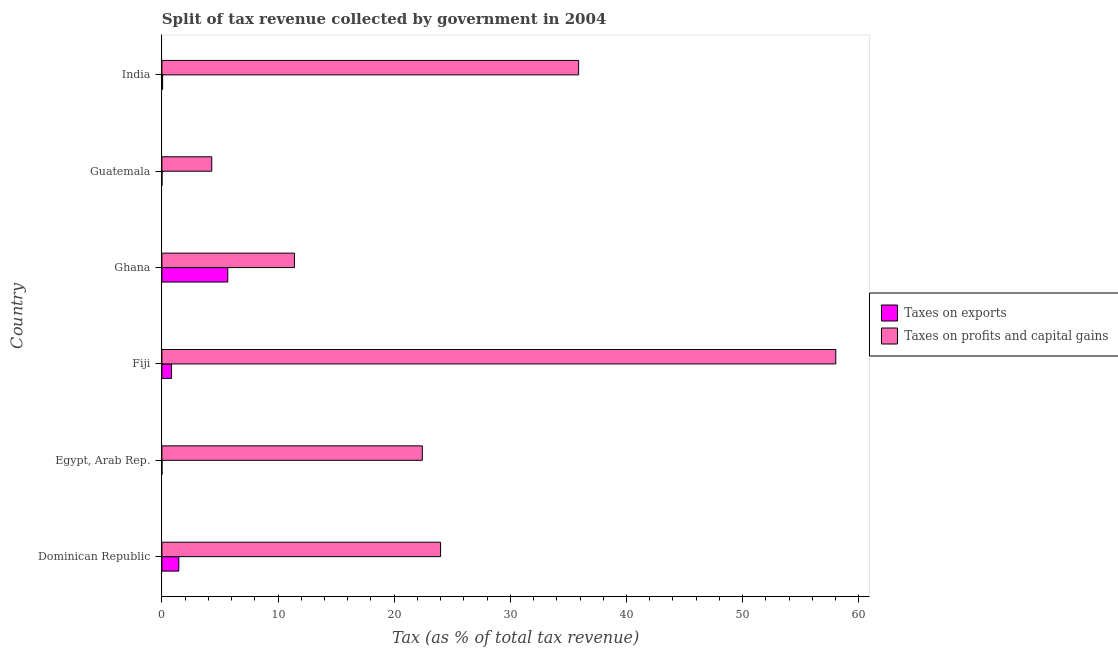How many groups of bars are there?
Your answer should be very brief. 6. Are the number of bars per tick equal to the number of legend labels?
Offer a very short reply. Yes. Are the number of bars on each tick of the Y-axis equal?
Ensure brevity in your answer.  Yes. How many bars are there on the 3rd tick from the top?
Your answer should be very brief. 2. What is the label of the 6th group of bars from the top?
Your response must be concise. Dominican Republic. In how many cases, is the number of bars for a given country not equal to the number of legend labels?
Ensure brevity in your answer.  0. What is the percentage of revenue obtained from taxes on exports in Egypt, Arab Rep.?
Provide a succinct answer. 0. Across all countries, what is the maximum percentage of revenue obtained from taxes on profits and capital gains?
Ensure brevity in your answer.  58.02. Across all countries, what is the minimum percentage of revenue obtained from taxes on exports?
Keep it short and to the point. 0. In which country was the percentage of revenue obtained from taxes on profits and capital gains maximum?
Your answer should be very brief. Fiji. In which country was the percentage of revenue obtained from taxes on exports minimum?
Your answer should be compact. Egypt, Arab Rep. What is the total percentage of revenue obtained from taxes on exports in the graph?
Make the answer very short. 8.03. What is the difference between the percentage of revenue obtained from taxes on exports in Dominican Republic and that in Guatemala?
Give a very brief answer. 1.45. What is the difference between the percentage of revenue obtained from taxes on exports in Dominican Republic and the percentage of revenue obtained from taxes on profits and capital gains in Egypt, Arab Rep.?
Ensure brevity in your answer.  -20.96. What is the average percentage of revenue obtained from taxes on exports per country?
Offer a terse response. 1.34. What is the difference between the percentage of revenue obtained from taxes on profits and capital gains and percentage of revenue obtained from taxes on exports in Fiji?
Provide a short and direct response. 57.19. What is the ratio of the percentage of revenue obtained from taxes on exports in Egypt, Arab Rep. to that in India?
Your response must be concise. 0.05. Is the difference between the percentage of revenue obtained from taxes on profits and capital gains in Dominican Republic and India greater than the difference between the percentage of revenue obtained from taxes on exports in Dominican Republic and India?
Ensure brevity in your answer.  No. What is the difference between the highest and the second highest percentage of revenue obtained from taxes on profits and capital gains?
Make the answer very short. 22.14. What is the difference between the highest and the lowest percentage of revenue obtained from taxes on profits and capital gains?
Ensure brevity in your answer.  53.72. What does the 1st bar from the top in Ghana represents?
Ensure brevity in your answer.  Taxes on profits and capital gains. What does the 2nd bar from the bottom in Guatemala represents?
Provide a short and direct response. Taxes on profits and capital gains. Are all the bars in the graph horizontal?
Offer a very short reply. Yes. Are the values on the major ticks of X-axis written in scientific E-notation?
Your answer should be very brief. No. How are the legend labels stacked?
Your answer should be very brief. Vertical. What is the title of the graph?
Ensure brevity in your answer.  Split of tax revenue collected by government in 2004. What is the label or title of the X-axis?
Provide a short and direct response. Tax (as % of total tax revenue). What is the label or title of the Y-axis?
Keep it short and to the point. Country. What is the Tax (as % of total tax revenue) in Taxes on exports in Dominican Republic?
Make the answer very short. 1.46. What is the Tax (as % of total tax revenue) in Taxes on profits and capital gains in Dominican Republic?
Your answer should be compact. 23.99. What is the Tax (as % of total tax revenue) of Taxes on exports in Egypt, Arab Rep.?
Provide a succinct answer. 0. What is the Tax (as % of total tax revenue) of Taxes on profits and capital gains in Egypt, Arab Rep.?
Provide a succinct answer. 22.42. What is the Tax (as % of total tax revenue) of Taxes on exports in Fiji?
Offer a very short reply. 0.83. What is the Tax (as % of total tax revenue) in Taxes on profits and capital gains in Fiji?
Give a very brief answer. 58.02. What is the Tax (as % of total tax revenue) of Taxes on exports in Ghana?
Provide a short and direct response. 5.67. What is the Tax (as % of total tax revenue) in Taxes on profits and capital gains in Ghana?
Make the answer very short. 11.41. What is the Tax (as % of total tax revenue) in Taxes on exports in Guatemala?
Provide a succinct answer. 0. What is the Tax (as % of total tax revenue) in Taxes on profits and capital gains in Guatemala?
Make the answer very short. 4.29. What is the Tax (as % of total tax revenue) in Taxes on exports in India?
Offer a terse response. 0.06. What is the Tax (as % of total tax revenue) in Taxes on profits and capital gains in India?
Your response must be concise. 35.88. Across all countries, what is the maximum Tax (as % of total tax revenue) in Taxes on exports?
Provide a short and direct response. 5.67. Across all countries, what is the maximum Tax (as % of total tax revenue) in Taxes on profits and capital gains?
Provide a short and direct response. 58.02. Across all countries, what is the minimum Tax (as % of total tax revenue) in Taxes on exports?
Provide a short and direct response. 0. Across all countries, what is the minimum Tax (as % of total tax revenue) in Taxes on profits and capital gains?
Provide a succinct answer. 4.29. What is the total Tax (as % of total tax revenue) in Taxes on exports in the graph?
Offer a very short reply. 8.03. What is the total Tax (as % of total tax revenue) in Taxes on profits and capital gains in the graph?
Keep it short and to the point. 156.01. What is the difference between the Tax (as % of total tax revenue) in Taxes on exports in Dominican Republic and that in Egypt, Arab Rep.?
Your answer should be compact. 1.45. What is the difference between the Tax (as % of total tax revenue) in Taxes on profits and capital gains in Dominican Republic and that in Egypt, Arab Rep.?
Offer a terse response. 1.57. What is the difference between the Tax (as % of total tax revenue) of Taxes on exports in Dominican Republic and that in Fiji?
Your answer should be very brief. 0.63. What is the difference between the Tax (as % of total tax revenue) in Taxes on profits and capital gains in Dominican Republic and that in Fiji?
Provide a short and direct response. -34.02. What is the difference between the Tax (as % of total tax revenue) in Taxes on exports in Dominican Republic and that in Ghana?
Keep it short and to the point. -4.22. What is the difference between the Tax (as % of total tax revenue) in Taxes on profits and capital gains in Dominican Republic and that in Ghana?
Keep it short and to the point. 12.58. What is the difference between the Tax (as % of total tax revenue) of Taxes on exports in Dominican Republic and that in Guatemala?
Offer a terse response. 1.45. What is the difference between the Tax (as % of total tax revenue) of Taxes on profits and capital gains in Dominican Republic and that in Guatemala?
Offer a very short reply. 19.7. What is the difference between the Tax (as % of total tax revenue) in Taxes on exports in Dominican Republic and that in India?
Provide a short and direct response. 1.39. What is the difference between the Tax (as % of total tax revenue) in Taxes on profits and capital gains in Dominican Republic and that in India?
Offer a terse response. -11.89. What is the difference between the Tax (as % of total tax revenue) of Taxes on exports in Egypt, Arab Rep. and that in Fiji?
Keep it short and to the point. -0.83. What is the difference between the Tax (as % of total tax revenue) of Taxes on profits and capital gains in Egypt, Arab Rep. and that in Fiji?
Your response must be concise. -35.6. What is the difference between the Tax (as % of total tax revenue) of Taxes on exports in Egypt, Arab Rep. and that in Ghana?
Give a very brief answer. -5.67. What is the difference between the Tax (as % of total tax revenue) of Taxes on profits and capital gains in Egypt, Arab Rep. and that in Ghana?
Ensure brevity in your answer.  11.01. What is the difference between the Tax (as % of total tax revenue) of Taxes on exports in Egypt, Arab Rep. and that in Guatemala?
Ensure brevity in your answer.  -0. What is the difference between the Tax (as % of total tax revenue) in Taxes on profits and capital gains in Egypt, Arab Rep. and that in Guatemala?
Make the answer very short. 18.13. What is the difference between the Tax (as % of total tax revenue) of Taxes on exports in Egypt, Arab Rep. and that in India?
Offer a very short reply. -0.06. What is the difference between the Tax (as % of total tax revenue) of Taxes on profits and capital gains in Egypt, Arab Rep. and that in India?
Offer a terse response. -13.46. What is the difference between the Tax (as % of total tax revenue) in Taxes on exports in Fiji and that in Ghana?
Give a very brief answer. -4.84. What is the difference between the Tax (as % of total tax revenue) of Taxes on profits and capital gains in Fiji and that in Ghana?
Your response must be concise. 46.61. What is the difference between the Tax (as % of total tax revenue) of Taxes on exports in Fiji and that in Guatemala?
Provide a short and direct response. 0.83. What is the difference between the Tax (as % of total tax revenue) of Taxes on profits and capital gains in Fiji and that in Guatemala?
Make the answer very short. 53.72. What is the difference between the Tax (as % of total tax revenue) of Taxes on exports in Fiji and that in India?
Offer a terse response. 0.77. What is the difference between the Tax (as % of total tax revenue) of Taxes on profits and capital gains in Fiji and that in India?
Offer a very short reply. 22.14. What is the difference between the Tax (as % of total tax revenue) of Taxes on exports in Ghana and that in Guatemala?
Your answer should be very brief. 5.67. What is the difference between the Tax (as % of total tax revenue) in Taxes on profits and capital gains in Ghana and that in Guatemala?
Make the answer very short. 7.12. What is the difference between the Tax (as % of total tax revenue) of Taxes on exports in Ghana and that in India?
Offer a terse response. 5.61. What is the difference between the Tax (as % of total tax revenue) of Taxes on profits and capital gains in Ghana and that in India?
Offer a terse response. -24.47. What is the difference between the Tax (as % of total tax revenue) of Taxes on exports in Guatemala and that in India?
Your answer should be compact. -0.06. What is the difference between the Tax (as % of total tax revenue) in Taxes on profits and capital gains in Guatemala and that in India?
Give a very brief answer. -31.59. What is the difference between the Tax (as % of total tax revenue) in Taxes on exports in Dominican Republic and the Tax (as % of total tax revenue) in Taxes on profits and capital gains in Egypt, Arab Rep.?
Keep it short and to the point. -20.96. What is the difference between the Tax (as % of total tax revenue) of Taxes on exports in Dominican Republic and the Tax (as % of total tax revenue) of Taxes on profits and capital gains in Fiji?
Your answer should be very brief. -56.56. What is the difference between the Tax (as % of total tax revenue) in Taxes on exports in Dominican Republic and the Tax (as % of total tax revenue) in Taxes on profits and capital gains in Ghana?
Make the answer very short. -9.95. What is the difference between the Tax (as % of total tax revenue) of Taxes on exports in Dominican Republic and the Tax (as % of total tax revenue) of Taxes on profits and capital gains in Guatemala?
Offer a terse response. -2.84. What is the difference between the Tax (as % of total tax revenue) of Taxes on exports in Dominican Republic and the Tax (as % of total tax revenue) of Taxes on profits and capital gains in India?
Make the answer very short. -34.42. What is the difference between the Tax (as % of total tax revenue) of Taxes on exports in Egypt, Arab Rep. and the Tax (as % of total tax revenue) of Taxes on profits and capital gains in Fiji?
Offer a very short reply. -58.01. What is the difference between the Tax (as % of total tax revenue) of Taxes on exports in Egypt, Arab Rep. and the Tax (as % of total tax revenue) of Taxes on profits and capital gains in Ghana?
Offer a very short reply. -11.41. What is the difference between the Tax (as % of total tax revenue) of Taxes on exports in Egypt, Arab Rep. and the Tax (as % of total tax revenue) of Taxes on profits and capital gains in Guatemala?
Ensure brevity in your answer.  -4.29. What is the difference between the Tax (as % of total tax revenue) of Taxes on exports in Egypt, Arab Rep. and the Tax (as % of total tax revenue) of Taxes on profits and capital gains in India?
Your answer should be compact. -35.88. What is the difference between the Tax (as % of total tax revenue) of Taxes on exports in Fiji and the Tax (as % of total tax revenue) of Taxes on profits and capital gains in Ghana?
Your answer should be very brief. -10.58. What is the difference between the Tax (as % of total tax revenue) of Taxes on exports in Fiji and the Tax (as % of total tax revenue) of Taxes on profits and capital gains in Guatemala?
Offer a very short reply. -3.46. What is the difference between the Tax (as % of total tax revenue) of Taxes on exports in Fiji and the Tax (as % of total tax revenue) of Taxes on profits and capital gains in India?
Your response must be concise. -35.05. What is the difference between the Tax (as % of total tax revenue) in Taxes on exports in Ghana and the Tax (as % of total tax revenue) in Taxes on profits and capital gains in Guatemala?
Offer a terse response. 1.38. What is the difference between the Tax (as % of total tax revenue) of Taxes on exports in Ghana and the Tax (as % of total tax revenue) of Taxes on profits and capital gains in India?
Your answer should be very brief. -30.21. What is the difference between the Tax (as % of total tax revenue) of Taxes on exports in Guatemala and the Tax (as % of total tax revenue) of Taxes on profits and capital gains in India?
Your answer should be compact. -35.87. What is the average Tax (as % of total tax revenue) of Taxes on exports per country?
Your response must be concise. 1.34. What is the average Tax (as % of total tax revenue) in Taxes on profits and capital gains per country?
Provide a succinct answer. 26. What is the difference between the Tax (as % of total tax revenue) in Taxes on exports and Tax (as % of total tax revenue) in Taxes on profits and capital gains in Dominican Republic?
Keep it short and to the point. -22.54. What is the difference between the Tax (as % of total tax revenue) of Taxes on exports and Tax (as % of total tax revenue) of Taxes on profits and capital gains in Egypt, Arab Rep.?
Make the answer very short. -22.42. What is the difference between the Tax (as % of total tax revenue) of Taxes on exports and Tax (as % of total tax revenue) of Taxes on profits and capital gains in Fiji?
Offer a terse response. -57.19. What is the difference between the Tax (as % of total tax revenue) in Taxes on exports and Tax (as % of total tax revenue) in Taxes on profits and capital gains in Ghana?
Make the answer very short. -5.74. What is the difference between the Tax (as % of total tax revenue) of Taxes on exports and Tax (as % of total tax revenue) of Taxes on profits and capital gains in Guatemala?
Offer a very short reply. -4.29. What is the difference between the Tax (as % of total tax revenue) in Taxes on exports and Tax (as % of total tax revenue) in Taxes on profits and capital gains in India?
Provide a succinct answer. -35.82. What is the ratio of the Tax (as % of total tax revenue) of Taxes on exports in Dominican Republic to that in Egypt, Arab Rep.?
Keep it short and to the point. 488.65. What is the ratio of the Tax (as % of total tax revenue) in Taxes on profits and capital gains in Dominican Republic to that in Egypt, Arab Rep.?
Your answer should be compact. 1.07. What is the ratio of the Tax (as % of total tax revenue) in Taxes on exports in Dominican Republic to that in Fiji?
Provide a short and direct response. 1.75. What is the ratio of the Tax (as % of total tax revenue) in Taxes on profits and capital gains in Dominican Republic to that in Fiji?
Your response must be concise. 0.41. What is the ratio of the Tax (as % of total tax revenue) of Taxes on exports in Dominican Republic to that in Ghana?
Your answer should be compact. 0.26. What is the ratio of the Tax (as % of total tax revenue) in Taxes on profits and capital gains in Dominican Republic to that in Ghana?
Your response must be concise. 2.1. What is the ratio of the Tax (as % of total tax revenue) of Taxes on exports in Dominican Republic to that in Guatemala?
Ensure brevity in your answer.  320.22. What is the ratio of the Tax (as % of total tax revenue) of Taxes on profits and capital gains in Dominican Republic to that in Guatemala?
Offer a very short reply. 5.59. What is the ratio of the Tax (as % of total tax revenue) in Taxes on exports in Dominican Republic to that in India?
Make the answer very short. 23.48. What is the ratio of the Tax (as % of total tax revenue) of Taxes on profits and capital gains in Dominican Republic to that in India?
Ensure brevity in your answer.  0.67. What is the ratio of the Tax (as % of total tax revenue) in Taxes on exports in Egypt, Arab Rep. to that in Fiji?
Provide a succinct answer. 0. What is the ratio of the Tax (as % of total tax revenue) in Taxes on profits and capital gains in Egypt, Arab Rep. to that in Fiji?
Offer a very short reply. 0.39. What is the ratio of the Tax (as % of total tax revenue) of Taxes on profits and capital gains in Egypt, Arab Rep. to that in Ghana?
Offer a terse response. 1.97. What is the ratio of the Tax (as % of total tax revenue) in Taxes on exports in Egypt, Arab Rep. to that in Guatemala?
Your response must be concise. 0.66. What is the ratio of the Tax (as % of total tax revenue) of Taxes on profits and capital gains in Egypt, Arab Rep. to that in Guatemala?
Ensure brevity in your answer.  5.22. What is the ratio of the Tax (as % of total tax revenue) of Taxes on exports in Egypt, Arab Rep. to that in India?
Make the answer very short. 0.05. What is the ratio of the Tax (as % of total tax revenue) of Taxes on profits and capital gains in Egypt, Arab Rep. to that in India?
Provide a short and direct response. 0.62. What is the ratio of the Tax (as % of total tax revenue) of Taxes on exports in Fiji to that in Ghana?
Provide a succinct answer. 0.15. What is the ratio of the Tax (as % of total tax revenue) of Taxes on profits and capital gains in Fiji to that in Ghana?
Ensure brevity in your answer.  5.08. What is the ratio of the Tax (as % of total tax revenue) of Taxes on exports in Fiji to that in Guatemala?
Your answer should be very brief. 182.68. What is the ratio of the Tax (as % of total tax revenue) in Taxes on profits and capital gains in Fiji to that in Guatemala?
Ensure brevity in your answer.  13.52. What is the ratio of the Tax (as % of total tax revenue) in Taxes on exports in Fiji to that in India?
Keep it short and to the point. 13.4. What is the ratio of the Tax (as % of total tax revenue) in Taxes on profits and capital gains in Fiji to that in India?
Your answer should be compact. 1.62. What is the ratio of the Tax (as % of total tax revenue) of Taxes on exports in Ghana to that in Guatemala?
Your answer should be compact. 1248.13. What is the ratio of the Tax (as % of total tax revenue) in Taxes on profits and capital gains in Ghana to that in Guatemala?
Offer a very short reply. 2.66. What is the ratio of the Tax (as % of total tax revenue) in Taxes on exports in Ghana to that in India?
Make the answer very short. 91.54. What is the ratio of the Tax (as % of total tax revenue) of Taxes on profits and capital gains in Ghana to that in India?
Provide a short and direct response. 0.32. What is the ratio of the Tax (as % of total tax revenue) of Taxes on exports in Guatemala to that in India?
Provide a short and direct response. 0.07. What is the ratio of the Tax (as % of total tax revenue) of Taxes on profits and capital gains in Guatemala to that in India?
Your answer should be very brief. 0.12. What is the difference between the highest and the second highest Tax (as % of total tax revenue) in Taxes on exports?
Provide a succinct answer. 4.22. What is the difference between the highest and the second highest Tax (as % of total tax revenue) of Taxes on profits and capital gains?
Your response must be concise. 22.14. What is the difference between the highest and the lowest Tax (as % of total tax revenue) in Taxes on exports?
Your response must be concise. 5.67. What is the difference between the highest and the lowest Tax (as % of total tax revenue) of Taxes on profits and capital gains?
Your response must be concise. 53.72. 